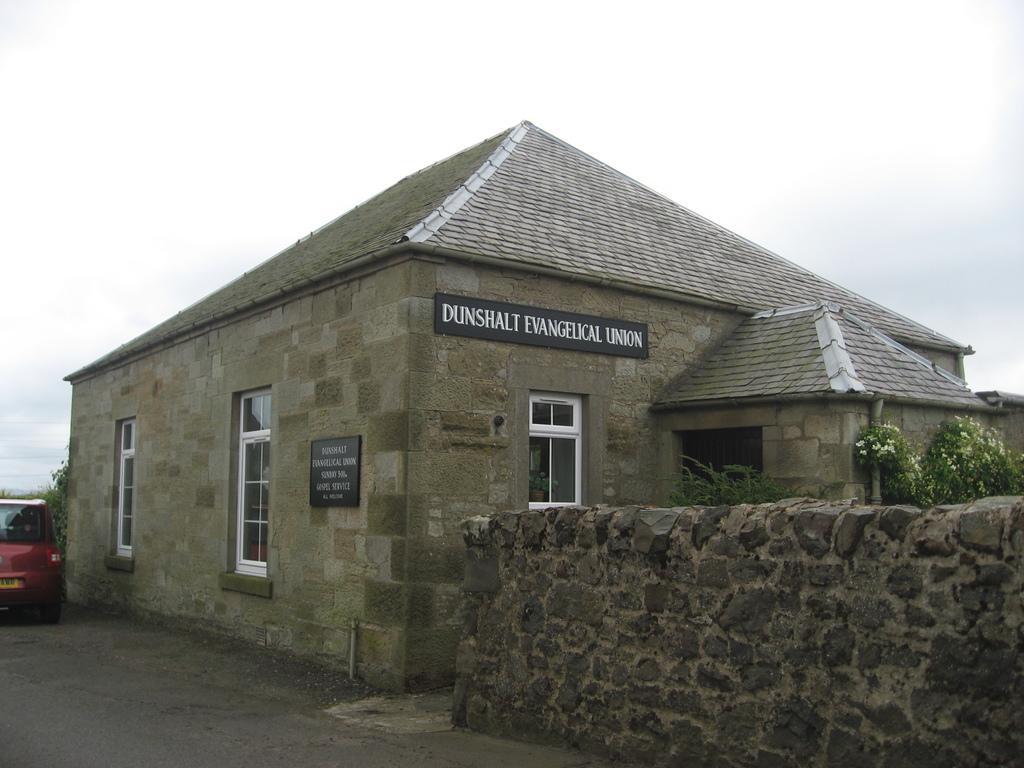Could you give a brief overview of what you see in this image? Here we can see a house, car, windows, boards, plants, flowers, and a wall. In the background there is sky. 